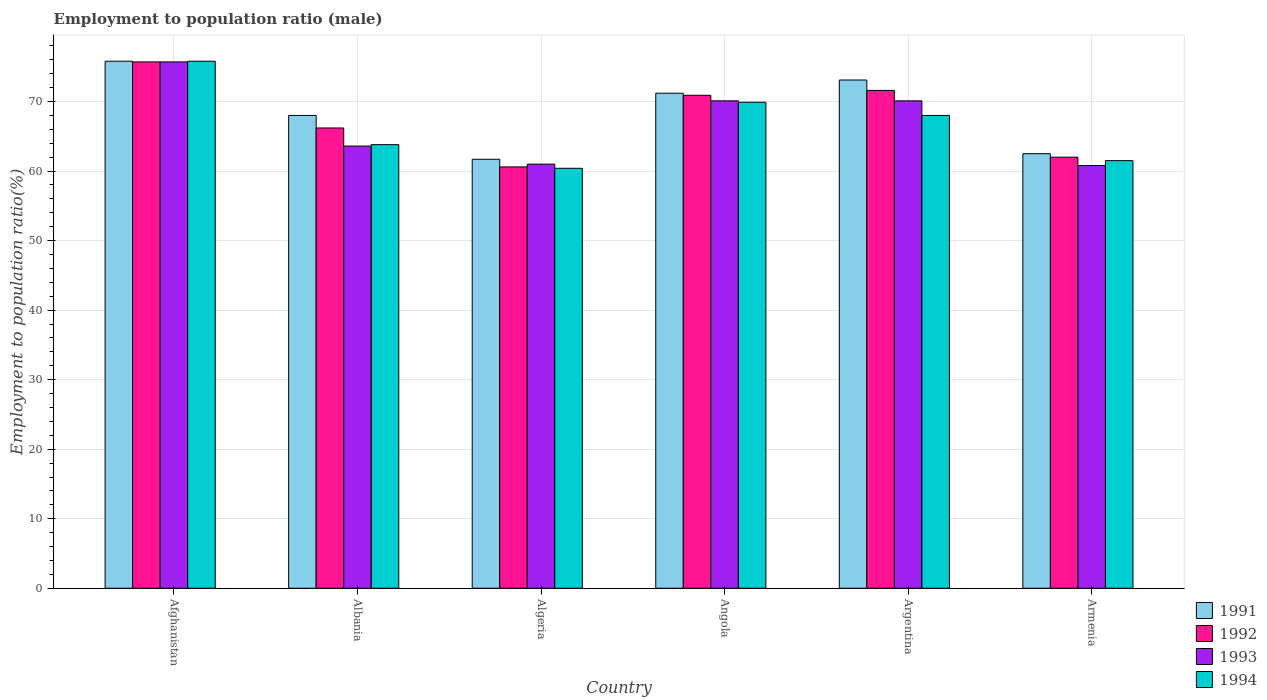Are the number of bars per tick equal to the number of legend labels?
Ensure brevity in your answer.  Yes. Are the number of bars on each tick of the X-axis equal?
Your answer should be very brief. Yes. How many bars are there on the 3rd tick from the left?
Give a very brief answer. 4. How many bars are there on the 6th tick from the right?
Make the answer very short. 4. What is the label of the 4th group of bars from the left?
Provide a short and direct response. Angola. In how many cases, is the number of bars for a given country not equal to the number of legend labels?
Provide a short and direct response. 0. Across all countries, what is the maximum employment to population ratio in 1993?
Offer a terse response. 75.7. Across all countries, what is the minimum employment to population ratio in 1993?
Make the answer very short. 60.8. In which country was the employment to population ratio in 1992 maximum?
Provide a short and direct response. Afghanistan. In which country was the employment to population ratio in 1992 minimum?
Your answer should be compact. Algeria. What is the total employment to population ratio in 1991 in the graph?
Offer a terse response. 412.3. What is the difference between the employment to population ratio in 1991 in Afghanistan and that in Algeria?
Provide a short and direct response. 14.1. What is the difference between the employment to population ratio in 1992 in Algeria and the employment to population ratio in 1991 in Albania?
Your response must be concise. -7.4. What is the average employment to population ratio in 1992 per country?
Make the answer very short. 67.83. What is the difference between the employment to population ratio of/in 1993 and employment to population ratio of/in 1994 in Afghanistan?
Ensure brevity in your answer.  -0.1. What is the ratio of the employment to population ratio in 1993 in Algeria to that in Armenia?
Ensure brevity in your answer.  1. What is the difference between the highest and the second highest employment to population ratio in 1991?
Provide a succinct answer. -2.7. What is the difference between the highest and the lowest employment to population ratio in 1991?
Ensure brevity in your answer.  14.1. In how many countries, is the employment to population ratio in 1994 greater than the average employment to population ratio in 1994 taken over all countries?
Your answer should be very brief. 3. Is it the case that in every country, the sum of the employment to population ratio in 1993 and employment to population ratio in 1994 is greater than the sum of employment to population ratio in 1991 and employment to population ratio in 1992?
Your answer should be compact. No. What does the 2nd bar from the right in Armenia represents?
Provide a succinct answer. 1993. Is it the case that in every country, the sum of the employment to population ratio in 1991 and employment to population ratio in 1994 is greater than the employment to population ratio in 1992?
Provide a succinct answer. Yes. What is the difference between two consecutive major ticks on the Y-axis?
Provide a short and direct response. 10. Are the values on the major ticks of Y-axis written in scientific E-notation?
Provide a short and direct response. No. Where does the legend appear in the graph?
Provide a succinct answer. Bottom right. How many legend labels are there?
Give a very brief answer. 4. What is the title of the graph?
Keep it short and to the point. Employment to population ratio (male). Does "1976" appear as one of the legend labels in the graph?
Make the answer very short. No. What is the label or title of the X-axis?
Your response must be concise. Country. What is the label or title of the Y-axis?
Offer a terse response. Employment to population ratio(%). What is the Employment to population ratio(%) in 1991 in Afghanistan?
Your answer should be compact. 75.8. What is the Employment to population ratio(%) of 1992 in Afghanistan?
Offer a very short reply. 75.7. What is the Employment to population ratio(%) in 1993 in Afghanistan?
Provide a short and direct response. 75.7. What is the Employment to population ratio(%) in 1994 in Afghanistan?
Your answer should be compact. 75.8. What is the Employment to population ratio(%) in 1991 in Albania?
Offer a terse response. 68. What is the Employment to population ratio(%) in 1992 in Albania?
Provide a short and direct response. 66.2. What is the Employment to population ratio(%) in 1993 in Albania?
Offer a very short reply. 63.6. What is the Employment to population ratio(%) of 1994 in Albania?
Keep it short and to the point. 63.8. What is the Employment to population ratio(%) of 1991 in Algeria?
Provide a succinct answer. 61.7. What is the Employment to population ratio(%) of 1992 in Algeria?
Your answer should be very brief. 60.6. What is the Employment to population ratio(%) in 1993 in Algeria?
Provide a succinct answer. 61. What is the Employment to population ratio(%) in 1994 in Algeria?
Provide a succinct answer. 60.4. What is the Employment to population ratio(%) of 1991 in Angola?
Make the answer very short. 71.2. What is the Employment to population ratio(%) of 1992 in Angola?
Offer a very short reply. 70.9. What is the Employment to population ratio(%) of 1993 in Angola?
Your answer should be very brief. 70.1. What is the Employment to population ratio(%) in 1994 in Angola?
Ensure brevity in your answer.  69.9. What is the Employment to population ratio(%) in 1991 in Argentina?
Give a very brief answer. 73.1. What is the Employment to population ratio(%) in 1992 in Argentina?
Give a very brief answer. 71.6. What is the Employment to population ratio(%) of 1993 in Argentina?
Provide a succinct answer. 70.1. What is the Employment to population ratio(%) of 1994 in Argentina?
Offer a terse response. 68. What is the Employment to population ratio(%) in 1991 in Armenia?
Offer a very short reply. 62.5. What is the Employment to population ratio(%) in 1992 in Armenia?
Your response must be concise. 62. What is the Employment to population ratio(%) of 1993 in Armenia?
Ensure brevity in your answer.  60.8. What is the Employment to population ratio(%) of 1994 in Armenia?
Ensure brevity in your answer.  61.5. Across all countries, what is the maximum Employment to population ratio(%) in 1991?
Offer a terse response. 75.8. Across all countries, what is the maximum Employment to population ratio(%) of 1992?
Keep it short and to the point. 75.7. Across all countries, what is the maximum Employment to population ratio(%) in 1993?
Ensure brevity in your answer.  75.7. Across all countries, what is the maximum Employment to population ratio(%) of 1994?
Your answer should be very brief. 75.8. Across all countries, what is the minimum Employment to population ratio(%) in 1991?
Your response must be concise. 61.7. Across all countries, what is the minimum Employment to population ratio(%) in 1992?
Your answer should be compact. 60.6. Across all countries, what is the minimum Employment to population ratio(%) of 1993?
Provide a short and direct response. 60.8. Across all countries, what is the minimum Employment to population ratio(%) of 1994?
Your response must be concise. 60.4. What is the total Employment to population ratio(%) of 1991 in the graph?
Make the answer very short. 412.3. What is the total Employment to population ratio(%) in 1992 in the graph?
Ensure brevity in your answer.  407. What is the total Employment to population ratio(%) of 1993 in the graph?
Your answer should be very brief. 401.3. What is the total Employment to population ratio(%) of 1994 in the graph?
Make the answer very short. 399.4. What is the difference between the Employment to population ratio(%) of 1991 in Afghanistan and that in Albania?
Give a very brief answer. 7.8. What is the difference between the Employment to population ratio(%) in 1994 in Afghanistan and that in Albania?
Offer a terse response. 12. What is the difference between the Employment to population ratio(%) of 1993 in Afghanistan and that in Algeria?
Your response must be concise. 14.7. What is the difference between the Employment to population ratio(%) in 1994 in Afghanistan and that in Algeria?
Ensure brevity in your answer.  15.4. What is the difference between the Employment to population ratio(%) of 1993 in Afghanistan and that in Angola?
Your answer should be very brief. 5.6. What is the difference between the Employment to population ratio(%) of 1994 in Afghanistan and that in Angola?
Your response must be concise. 5.9. What is the difference between the Employment to population ratio(%) of 1991 in Afghanistan and that in Argentina?
Ensure brevity in your answer.  2.7. What is the difference between the Employment to population ratio(%) in 1992 in Afghanistan and that in Argentina?
Ensure brevity in your answer.  4.1. What is the difference between the Employment to population ratio(%) in 1993 in Afghanistan and that in Argentina?
Keep it short and to the point. 5.6. What is the difference between the Employment to population ratio(%) of 1991 in Afghanistan and that in Armenia?
Make the answer very short. 13.3. What is the difference between the Employment to population ratio(%) in 1992 in Afghanistan and that in Armenia?
Your response must be concise. 13.7. What is the difference between the Employment to population ratio(%) in 1994 in Afghanistan and that in Armenia?
Offer a terse response. 14.3. What is the difference between the Employment to population ratio(%) of 1992 in Albania and that in Algeria?
Your response must be concise. 5.6. What is the difference between the Employment to population ratio(%) in 1993 in Albania and that in Algeria?
Offer a terse response. 2.6. What is the difference between the Employment to population ratio(%) of 1994 in Albania and that in Algeria?
Ensure brevity in your answer.  3.4. What is the difference between the Employment to population ratio(%) of 1991 in Albania and that in Angola?
Your response must be concise. -3.2. What is the difference between the Employment to population ratio(%) of 1993 in Albania and that in Angola?
Offer a very short reply. -6.5. What is the difference between the Employment to population ratio(%) of 1994 in Albania and that in Angola?
Provide a short and direct response. -6.1. What is the difference between the Employment to population ratio(%) of 1991 in Albania and that in Argentina?
Provide a succinct answer. -5.1. What is the difference between the Employment to population ratio(%) of 1994 in Albania and that in Argentina?
Make the answer very short. -4.2. What is the difference between the Employment to population ratio(%) of 1993 in Albania and that in Armenia?
Offer a terse response. 2.8. What is the difference between the Employment to population ratio(%) of 1994 in Algeria and that in Angola?
Keep it short and to the point. -9.5. What is the difference between the Employment to population ratio(%) in 1994 in Algeria and that in Argentina?
Ensure brevity in your answer.  -7.6. What is the difference between the Employment to population ratio(%) of 1992 in Algeria and that in Armenia?
Your answer should be very brief. -1.4. What is the difference between the Employment to population ratio(%) in 1991 in Angola and that in Armenia?
Provide a succinct answer. 8.7. What is the difference between the Employment to population ratio(%) in 1994 in Angola and that in Armenia?
Offer a very short reply. 8.4. What is the difference between the Employment to population ratio(%) of 1992 in Argentina and that in Armenia?
Your response must be concise. 9.6. What is the difference between the Employment to population ratio(%) of 1994 in Argentina and that in Armenia?
Keep it short and to the point. 6.5. What is the difference between the Employment to population ratio(%) in 1991 in Afghanistan and the Employment to population ratio(%) in 1992 in Albania?
Your response must be concise. 9.6. What is the difference between the Employment to population ratio(%) of 1991 in Afghanistan and the Employment to population ratio(%) of 1993 in Albania?
Keep it short and to the point. 12.2. What is the difference between the Employment to population ratio(%) in 1991 in Afghanistan and the Employment to population ratio(%) in 1994 in Albania?
Ensure brevity in your answer.  12. What is the difference between the Employment to population ratio(%) of 1992 in Afghanistan and the Employment to population ratio(%) of 1994 in Albania?
Your answer should be compact. 11.9. What is the difference between the Employment to population ratio(%) of 1993 in Afghanistan and the Employment to population ratio(%) of 1994 in Albania?
Offer a very short reply. 11.9. What is the difference between the Employment to population ratio(%) of 1991 in Afghanistan and the Employment to population ratio(%) of 1992 in Algeria?
Offer a very short reply. 15.2. What is the difference between the Employment to population ratio(%) in 1992 in Afghanistan and the Employment to population ratio(%) in 1993 in Algeria?
Offer a terse response. 14.7. What is the difference between the Employment to population ratio(%) in 1991 in Afghanistan and the Employment to population ratio(%) in 1993 in Angola?
Your answer should be very brief. 5.7. What is the difference between the Employment to population ratio(%) of 1992 in Afghanistan and the Employment to population ratio(%) of 1994 in Angola?
Give a very brief answer. 5.8. What is the difference between the Employment to population ratio(%) of 1993 in Afghanistan and the Employment to population ratio(%) of 1994 in Angola?
Provide a succinct answer. 5.8. What is the difference between the Employment to population ratio(%) in 1991 in Afghanistan and the Employment to population ratio(%) in 1992 in Argentina?
Offer a very short reply. 4.2. What is the difference between the Employment to population ratio(%) in 1992 in Afghanistan and the Employment to population ratio(%) in 1993 in Argentina?
Ensure brevity in your answer.  5.6. What is the difference between the Employment to population ratio(%) in 1993 in Afghanistan and the Employment to population ratio(%) in 1994 in Argentina?
Ensure brevity in your answer.  7.7. What is the difference between the Employment to population ratio(%) in 1991 in Afghanistan and the Employment to population ratio(%) in 1992 in Armenia?
Your answer should be very brief. 13.8. What is the difference between the Employment to population ratio(%) of 1992 in Afghanistan and the Employment to population ratio(%) of 1994 in Armenia?
Your answer should be very brief. 14.2. What is the difference between the Employment to population ratio(%) in 1991 in Albania and the Employment to population ratio(%) in 1992 in Algeria?
Make the answer very short. 7.4. What is the difference between the Employment to population ratio(%) in 1992 in Albania and the Employment to population ratio(%) in 1994 in Algeria?
Your answer should be very brief. 5.8. What is the difference between the Employment to population ratio(%) in 1993 in Albania and the Employment to population ratio(%) in 1994 in Algeria?
Ensure brevity in your answer.  3.2. What is the difference between the Employment to population ratio(%) of 1991 in Albania and the Employment to population ratio(%) of 1992 in Angola?
Offer a terse response. -2.9. What is the difference between the Employment to population ratio(%) in 1991 in Albania and the Employment to population ratio(%) in 1994 in Angola?
Your answer should be compact. -1.9. What is the difference between the Employment to population ratio(%) of 1992 in Albania and the Employment to population ratio(%) of 1994 in Angola?
Make the answer very short. -3.7. What is the difference between the Employment to population ratio(%) of 1993 in Albania and the Employment to population ratio(%) of 1994 in Angola?
Make the answer very short. -6.3. What is the difference between the Employment to population ratio(%) of 1991 in Albania and the Employment to population ratio(%) of 1992 in Argentina?
Make the answer very short. -3.6. What is the difference between the Employment to population ratio(%) of 1991 in Albania and the Employment to population ratio(%) of 1993 in Argentina?
Provide a short and direct response. -2.1. What is the difference between the Employment to population ratio(%) in 1991 in Albania and the Employment to population ratio(%) in 1994 in Armenia?
Your answer should be very brief. 6.5. What is the difference between the Employment to population ratio(%) of 1992 in Albania and the Employment to population ratio(%) of 1994 in Armenia?
Offer a terse response. 4.7. What is the difference between the Employment to population ratio(%) of 1991 in Algeria and the Employment to population ratio(%) of 1992 in Angola?
Make the answer very short. -9.2. What is the difference between the Employment to population ratio(%) in 1991 in Algeria and the Employment to population ratio(%) in 1993 in Angola?
Provide a short and direct response. -8.4. What is the difference between the Employment to population ratio(%) in 1992 in Algeria and the Employment to population ratio(%) in 1994 in Angola?
Keep it short and to the point. -9.3. What is the difference between the Employment to population ratio(%) in 1993 in Algeria and the Employment to population ratio(%) in 1994 in Argentina?
Your response must be concise. -7. What is the difference between the Employment to population ratio(%) in 1992 in Algeria and the Employment to population ratio(%) in 1993 in Armenia?
Give a very brief answer. -0.2. What is the difference between the Employment to population ratio(%) of 1993 in Algeria and the Employment to population ratio(%) of 1994 in Armenia?
Make the answer very short. -0.5. What is the difference between the Employment to population ratio(%) in 1992 in Angola and the Employment to population ratio(%) in 1994 in Argentina?
Ensure brevity in your answer.  2.9. What is the difference between the Employment to population ratio(%) of 1991 in Angola and the Employment to population ratio(%) of 1992 in Armenia?
Make the answer very short. 9.2. What is the difference between the Employment to population ratio(%) in 1991 in Angola and the Employment to population ratio(%) in 1993 in Armenia?
Ensure brevity in your answer.  10.4. What is the difference between the Employment to population ratio(%) of 1991 in Angola and the Employment to population ratio(%) of 1994 in Armenia?
Provide a short and direct response. 9.7. What is the difference between the Employment to population ratio(%) of 1993 in Angola and the Employment to population ratio(%) of 1994 in Armenia?
Make the answer very short. 8.6. What is the difference between the Employment to population ratio(%) of 1991 in Argentina and the Employment to population ratio(%) of 1992 in Armenia?
Your answer should be very brief. 11.1. What is the difference between the Employment to population ratio(%) in 1992 in Argentina and the Employment to population ratio(%) in 1993 in Armenia?
Ensure brevity in your answer.  10.8. What is the difference between the Employment to population ratio(%) in 1993 in Argentina and the Employment to population ratio(%) in 1994 in Armenia?
Keep it short and to the point. 8.6. What is the average Employment to population ratio(%) in 1991 per country?
Your answer should be compact. 68.72. What is the average Employment to population ratio(%) in 1992 per country?
Offer a terse response. 67.83. What is the average Employment to population ratio(%) in 1993 per country?
Your response must be concise. 66.88. What is the average Employment to population ratio(%) in 1994 per country?
Give a very brief answer. 66.57. What is the difference between the Employment to population ratio(%) of 1991 and Employment to population ratio(%) of 1992 in Afghanistan?
Make the answer very short. 0.1. What is the difference between the Employment to population ratio(%) of 1992 and Employment to population ratio(%) of 1994 in Afghanistan?
Provide a short and direct response. -0.1. What is the difference between the Employment to population ratio(%) in 1992 and Employment to population ratio(%) in 1993 in Albania?
Make the answer very short. 2.6. What is the difference between the Employment to population ratio(%) in 1992 and Employment to population ratio(%) in 1994 in Albania?
Provide a succinct answer. 2.4. What is the difference between the Employment to population ratio(%) in 1991 and Employment to population ratio(%) in 1993 in Algeria?
Keep it short and to the point. 0.7. What is the difference between the Employment to population ratio(%) of 1991 and Employment to population ratio(%) of 1994 in Algeria?
Make the answer very short. 1.3. What is the difference between the Employment to population ratio(%) in 1993 and Employment to population ratio(%) in 1994 in Algeria?
Keep it short and to the point. 0.6. What is the difference between the Employment to population ratio(%) in 1991 and Employment to population ratio(%) in 1993 in Angola?
Keep it short and to the point. 1.1. What is the difference between the Employment to population ratio(%) of 1992 and Employment to population ratio(%) of 1993 in Angola?
Make the answer very short. 0.8. What is the difference between the Employment to population ratio(%) in 1992 and Employment to population ratio(%) in 1994 in Argentina?
Your response must be concise. 3.6. What is the difference between the Employment to population ratio(%) in 1991 and Employment to population ratio(%) in 1993 in Armenia?
Make the answer very short. 1.7. What is the ratio of the Employment to population ratio(%) in 1991 in Afghanistan to that in Albania?
Provide a succinct answer. 1.11. What is the ratio of the Employment to population ratio(%) in 1992 in Afghanistan to that in Albania?
Offer a terse response. 1.14. What is the ratio of the Employment to population ratio(%) of 1993 in Afghanistan to that in Albania?
Ensure brevity in your answer.  1.19. What is the ratio of the Employment to population ratio(%) of 1994 in Afghanistan to that in Albania?
Ensure brevity in your answer.  1.19. What is the ratio of the Employment to population ratio(%) in 1991 in Afghanistan to that in Algeria?
Provide a succinct answer. 1.23. What is the ratio of the Employment to population ratio(%) in 1992 in Afghanistan to that in Algeria?
Your answer should be very brief. 1.25. What is the ratio of the Employment to population ratio(%) of 1993 in Afghanistan to that in Algeria?
Ensure brevity in your answer.  1.24. What is the ratio of the Employment to population ratio(%) of 1994 in Afghanistan to that in Algeria?
Make the answer very short. 1.25. What is the ratio of the Employment to population ratio(%) of 1991 in Afghanistan to that in Angola?
Offer a very short reply. 1.06. What is the ratio of the Employment to population ratio(%) of 1992 in Afghanistan to that in Angola?
Provide a short and direct response. 1.07. What is the ratio of the Employment to population ratio(%) of 1993 in Afghanistan to that in Angola?
Offer a terse response. 1.08. What is the ratio of the Employment to population ratio(%) of 1994 in Afghanistan to that in Angola?
Offer a very short reply. 1.08. What is the ratio of the Employment to population ratio(%) in 1991 in Afghanistan to that in Argentina?
Provide a short and direct response. 1.04. What is the ratio of the Employment to population ratio(%) in 1992 in Afghanistan to that in Argentina?
Make the answer very short. 1.06. What is the ratio of the Employment to population ratio(%) of 1993 in Afghanistan to that in Argentina?
Offer a terse response. 1.08. What is the ratio of the Employment to population ratio(%) in 1994 in Afghanistan to that in Argentina?
Give a very brief answer. 1.11. What is the ratio of the Employment to population ratio(%) of 1991 in Afghanistan to that in Armenia?
Ensure brevity in your answer.  1.21. What is the ratio of the Employment to population ratio(%) of 1992 in Afghanistan to that in Armenia?
Offer a very short reply. 1.22. What is the ratio of the Employment to population ratio(%) in 1993 in Afghanistan to that in Armenia?
Provide a succinct answer. 1.25. What is the ratio of the Employment to population ratio(%) in 1994 in Afghanistan to that in Armenia?
Give a very brief answer. 1.23. What is the ratio of the Employment to population ratio(%) of 1991 in Albania to that in Algeria?
Provide a short and direct response. 1.1. What is the ratio of the Employment to population ratio(%) in 1992 in Albania to that in Algeria?
Offer a very short reply. 1.09. What is the ratio of the Employment to population ratio(%) of 1993 in Albania to that in Algeria?
Give a very brief answer. 1.04. What is the ratio of the Employment to population ratio(%) in 1994 in Albania to that in Algeria?
Offer a very short reply. 1.06. What is the ratio of the Employment to population ratio(%) of 1991 in Albania to that in Angola?
Provide a succinct answer. 0.96. What is the ratio of the Employment to population ratio(%) in 1992 in Albania to that in Angola?
Make the answer very short. 0.93. What is the ratio of the Employment to population ratio(%) in 1993 in Albania to that in Angola?
Your answer should be compact. 0.91. What is the ratio of the Employment to population ratio(%) of 1994 in Albania to that in Angola?
Provide a succinct answer. 0.91. What is the ratio of the Employment to population ratio(%) of 1991 in Albania to that in Argentina?
Provide a succinct answer. 0.93. What is the ratio of the Employment to population ratio(%) of 1992 in Albania to that in Argentina?
Your response must be concise. 0.92. What is the ratio of the Employment to population ratio(%) of 1993 in Albania to that in Argentina?
Give a very brief answer. 0.91. What is the ratio of the Employment to population ratio(%) of 1994 in Albania to that in Argentina?
Make the answer very short. 0.94. What is the ratio of the Employment to population ratio(%) of 1991 in Albania to that in Armenia?
Provide a short and direct response. 1.09. What is the ratio of the Employment to population ratio(%) in 1992 in Albania to that in Armenia?
Provide a short and direct response. 1.07. What is the ratio of the Employment to population ratio(%) of 1993 in Albania to that in Armenia?
Offer a terse response. 1.05. What is the ratio of the Employment to population ratio(%) in 1994 in Albania to that in Armenia?
Provide a succinct answer. 1.04. What is the ratio of the Employment to population ratio(%) of 1991 in Algeria to that in Angola?
Offer a terse response. 0.87. What is the ratio of the Employment to population ratio(%) in 1992 in Algeria to that in Angola?
Offer a terse response. 0.85. What is the ratio of the Employment to population ratio(%) of 1993 in Algeria to that in Angola?
Offer a terse response. 0.87. What is the ratio of the Employment to population ratio(%) of 1994 in Algeria to that in Angola?
Offer a very short reply. 0.86. What is the ratio of the Employment to population ratio(%) of 1991 in Algeria to that in Argentina?
Make the answer very short. 0.84. What is the ratio of the Employment to population ratio(%) of 1992 in Algeria to that in Argentina?
Make the answer very short. 0.85. What is the ratio of the Employment to population ratio(%) in 1993 in Algeria to that in Argentina?
Ensure brevity in your answer.  0.87. What is the ratio of the Employment to population ratio(%) in 1994 in Algeria to that in Argentina?
Your response must be concise. 0.89. What is the ratio of the Employment to population ratio(%) of 1991 in Algeria to that in Armenia?
Your answer should be compact. 0.99. What is the ratio of the Employment to population ratio(%) in 1992 in Algeria to that in Armenia?
Provide a succinct answer. 0.98. What is the ratio of the Employment to population ratio(%) in 1993 in Algeria to that in Armenia?
Ensure brevity in your answer.  1. What is the ratio of the Employment to population ratio(%) of 1994 in Algeria to that in Armenia?
Your answer should be compact. 0.98. What is the ratio of the Employment to population ratio(%) of 1991 in Angola to that in Argentina?
Ensure brevity in your answer.  0.97. What is the ratio of the Employment to population ratio(%) in 1992 in Angola to that in Argentina?
Your response must be concise. 0.99. What is the ratio of the Employment to population ratio(%) in 1993 in Angola to that in Argentina?
Provide a succinct answer. 1. What is the ratio of the Employment to population ratio(%) in 1994 in Angola to that in Argentina?
Provide a succinct answer. 1.03. What is the ratio of the Employment to population ratio(%) of 1991 in Angola to that in Armenia?
Your answer should be very brief. 1.14. What is the ratio of the Employment to population ratio(%) in 1992 in Angola to that in Armenia?
Offer a very short reply. 1.14. What is the ratio of the Employment to population ratio(%) of 1993 in Angola to that in Armenia?
Your answer should be very brief. 1.15. What is the ratio of the Employment to population ratio(%) in 1994 in Angola to that in Armenia?
Your response must be concise. 1.14. What is the ratio of the Employment to population ratio(%) of 1991 in Argentina to that in Armenia?
Offer a terse response. 1.17. What is the ratio of the Employment to population ratio(%) in 1992 in Argentina to that in Armenia?
Your answer should be very brief. 1.15. What is the ratio of the Employment to population ratio(%) of 1993 in Argentina to that in Armenia?
Make the answer very short. 1.15. What is the ratio of the Employment to population ratio(%) of 1994 in Argentina to that in Armenia?
Keep it short and to the point. 1.11. What is the difference between the highest and the lowest Employment to population ratio(%) in 1994?
Provide a succinct answer. 15.4. 